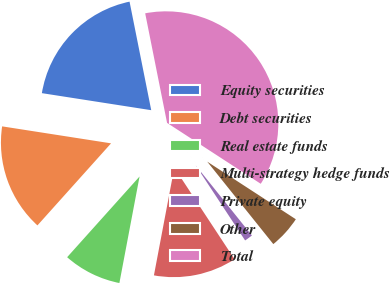<chart> <loc_0><loc_0><loc_500><loc_500><pie_chart><fcel>Equity securities<fcel>Debt securities<fcel>Real estate funds<fcel>Multi-strategy hedge funds<fcel>Private equity<fcel>Other<fcel>Total<nl><fcel>19.4%<fcel>15.82%<fcel>8.66%<fcel>12.24%<fcel>1.49%<fcel>5.07%<fcel>37.31%<nl></chart> 